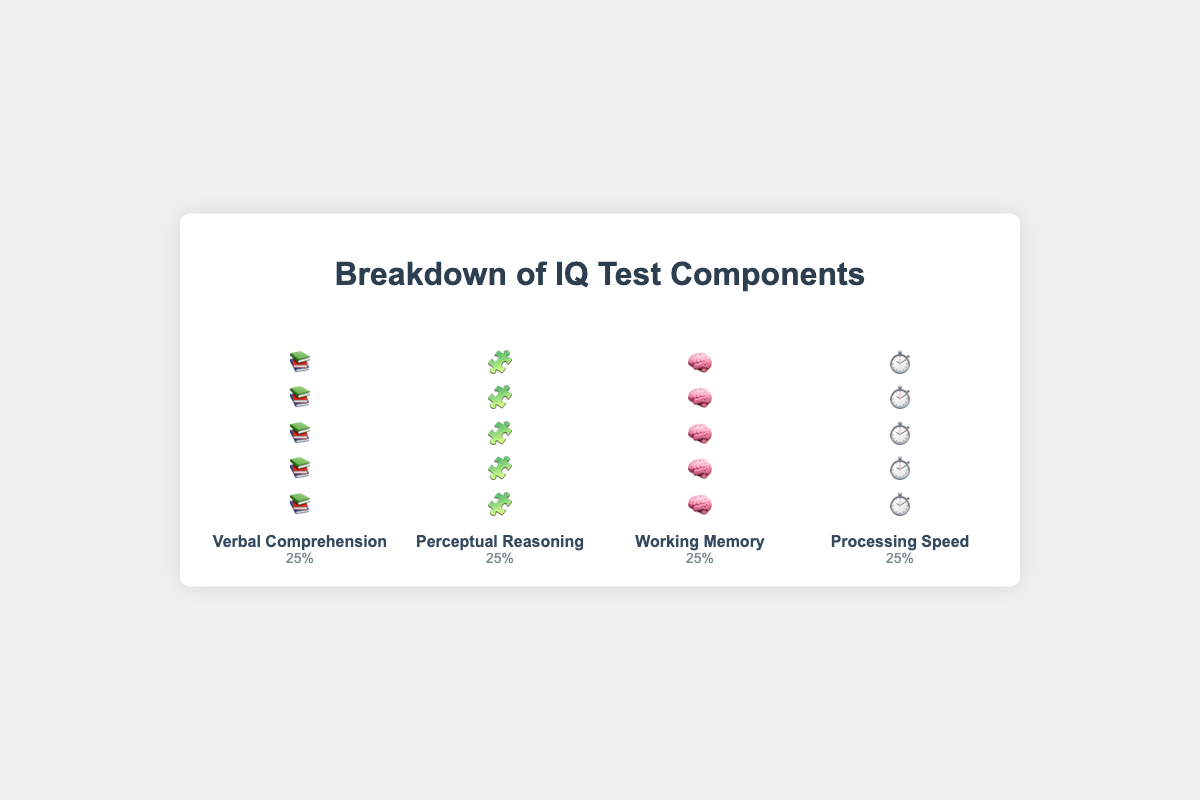Which component has the highest weight in the IQ test? All components have the same weight, which is 25%.
Answer: All components have the same weight How many icons are used to represent each component? Each component is represented by five icons arranged vertically.
Answer: 5 What percentage does the "Working Memory" component contribute to the overall IQ score? The figure shows "Working Memory" with a 25% weight.
Answer: 25% Which component uses 🧩 icons? The component "Perceptual Reasoning" uses 🧩 icons.
Answer: Perceptual Reasoning What do the icons represent in the isotype plot? Each icon in the isotype plot represents a 5% contribution to the overall IQ score for a particular component.
Answer: 5% Compare the weight of "Verbal Comprehension" and "Processing Speed". The weight of "Verbal Comprehension" (25%) is equal to that of "Processing Speed" (25%).
Answer: Equal What is the total weight of "Perceptual Reasoning" and "Working Memory"? The weight of "Perceptual Reasoning" is 25% and "Working Memory" is 25%. Adding them gives 25% + 25% = 50%.
Answer: 50% If each component's weight is equally distributed, what fraction of the icons in one column represents the total IQ score? Each component is represented by five icons, which collectively contribute 25% of the total score. Since there are four components, the total number of icons is 20. Therefore, each icon represents 1/20 = 5% of the total score.
Answer: 1/20 Is "Processing Speed" more heavily weighted than "Verbal Comprehension"? Both "Processing Speed" and "Verbal Comprehension" have the same weight of 25%.
Answer: No How does the isotype plot visually communicate the weight of each component? The plot uses the same number of icons (five) per component to visually indicate that each component contributes equally (25%) to the overall IQ score.
Answer: By using the same number of icons for each component 